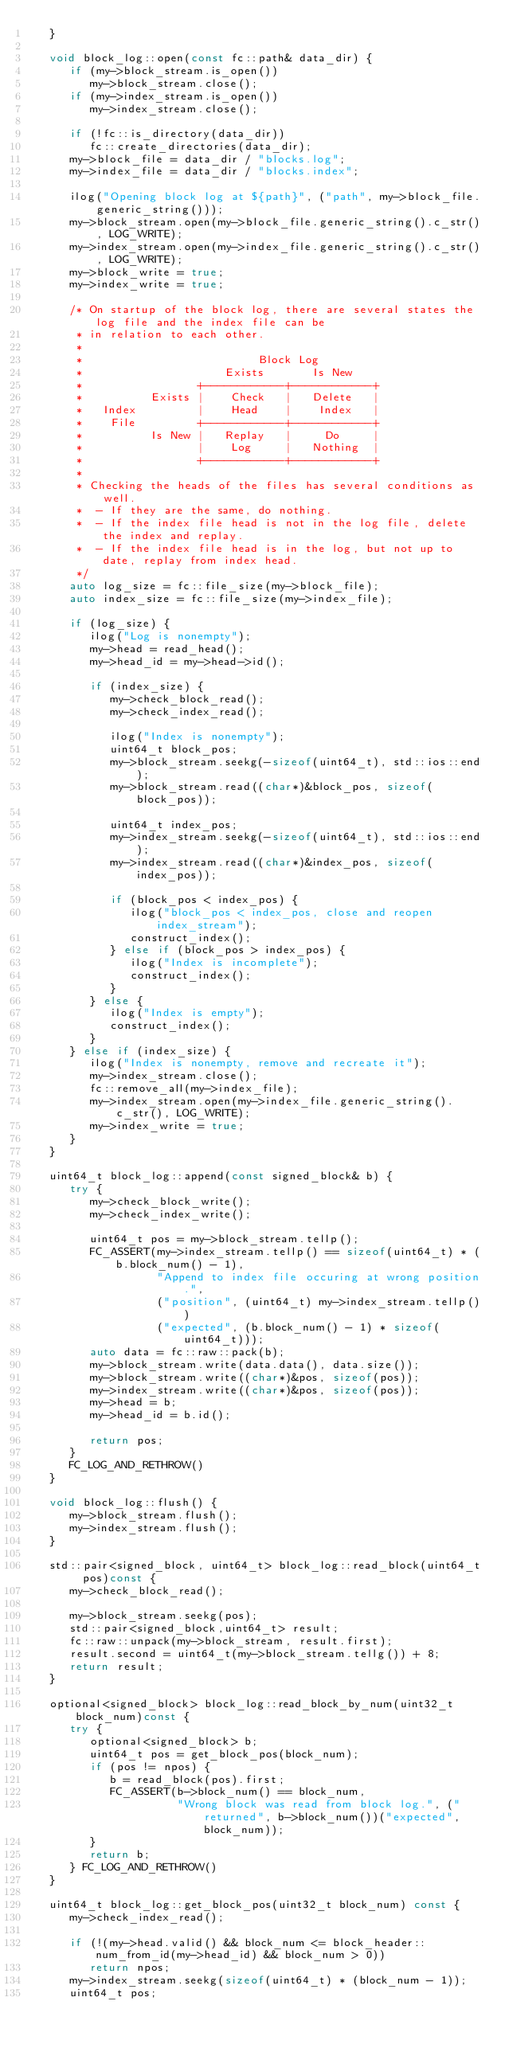<code> <loc_0><loc_0><loc_500><loc_500><_C++_>   }

   void block_log::open(const fc::path& data_dir) {
      if (my->block_stream.is_open())
         my->block_stream.close();
      if (my->index_stream.is_open())
         my->index_stream.close();

      if (!fc::is_directory(data_dir))
         fc::create_directories(data_dir);
      my->block_file = data_dir / "blocks.log";
      my->index_file = data_dir / "blocks.index";

      ilog("Opening block log at ${path}", ("path", my->block_file.generic_string()));
      my->block_stream.open(my->block_file.generic_string().c_str(), LOG_WRITE);
      my->index_stream.open(my->index_file.generic_string().c_str(), LOG_WRITE);
      my->block_write = true;
      my->index_write = true;

      /* On startup of the block log, there are several states the log file and the index file can be
       * in relation to each other.
       *
       *                          Block Log
       *                     Exists       Is New
       *                 +------------+------------+
       *          Exists |    Check   |   Delete   |
       *   Index         |    Head    |    Index   |
       *    File         +------------+------------+
       *          Is New |   Replay   |     Do     |
       *                 |    Log     |   Nothing  |
       *                 +------------+------------+
       *
       * Checking the heads of the files has several conditions as well.
       *  - If they are the same, do nothing.
       *  - If the index file head is not in the log file, delete the index and replay.
       *  - If the index file head is in the log, but not up to date, replay from index head.
       */
      auto log_size = fc::file_size(my->block_file);
      auto index_size = fc::file_size(my->index_file);

      if (log_size) {
         ilog("Log is nonempty");
         my->head = read_head();
         my->head_id = my->head->id();

         if (index_size) {
            my->check_block_read();
            my->check_index_read();

            ilog("Index is nonempty");
            uint64_t block_pos;
            my->block_stream.seekg(-sizeof(uint64_t), std::ios::end);
            my->block_stream.read((char*)&block_pos, sizeof(block_pos));

            uint64_t index_pos;
            my->index_stream.seekg(-sizeof(uint64_t), std::ios::end);
            my->index_stream.read((char*)&index_pos, sizeof(index_pos));

            if (block_pos < index_pos) {
               ilog("block_pos < index_pos, close and reopen index_stream");
               construct_index();
            } else if (block_pos > index_pos) {
               ilog("Index is incomplete");
               construct_index();
            }
         } else {
            ilog("Index is empty");
            construct_index();
         }
      } else if (index_size) {
         ilog("Index is nonempty, remove and recreate it");
         my->index_stream.close();
         fc::remove_all(my->index_file);
         my->index_stream.open(my->index_file.generic_string().c_str(), LOG_WRITE);
         my->index_write = true;
      }
   }

   uint64_t block_log::append(const signed_block& b) {
      try {
         my->check_block_write();
         my->check_index_write();

         uint64_t pos = my->block_stream.tellp();
         FC_ASSERT(my->index_stream.tellp() == sizeof(uint64_t) * (b.block_num() - 1),
                   "Append to index file occuring at wrong position.",
                   ("position", (uint64_t) my->index_stream.tellp())
                   ("expected", (b.block_num() - 1) * sizeof(uint64_t)));
         auto data = fc::raw::pack(b);
         my->block_stream.write(data.data(), data.size());
         my->block_stream.write((char*)&pos, sizeof(pos));
         my->index_stream.write((char*)&pos, sizeof(pos));
         my->head = b;
         my->head_id = b.id();

         return pos;
      }
      FC_LOG_AND_RETHROW()
   }

   void block_log::flush() {
      my->block_stream.flush();
      my->index_stream.flush();
   }

   std::pair<signed_block, uint64_t> block_log::read_block(uint64_t pos)const {
      my->check_block_read();

      my->block_stream.seekg(pos);
      std::pair<signed_block,uint64_t> result;
      fc::raw::unpack(my->block_stream, result.first);
      result.second = uint64_t(my->block_stream.tellg()) + 8;
      return result;
   }

   optional<signed_block> block_log::read_block_by_num(uint32_t block_num)const {
      try {
         optional<signed_block> b;
         uint64_t pos = get_block_pos(block_num);
         if (pos != npos) {
            b = read_block(pos).first;
            FC_ASSERT(b->block_num() == block_num,
                      "Wrong block was read from block log.", ("returned", b->block_num())("expected", block_num));
         }
         return b;
      } FC_LOG_AND_RETHROW()
   }

   uint64_t block_log::get_block_pos(uint32_t block_num) const {
      my->check_index_read();

      if (!(my->head.valid() && block_num <= block_header::num_from_id(my->head_id) && block_num > 0))
         return npos;
      my->index_stream.seekg(sizeof(uint64_t) * (block_num - 1));
      uint64_t pos;</code> 